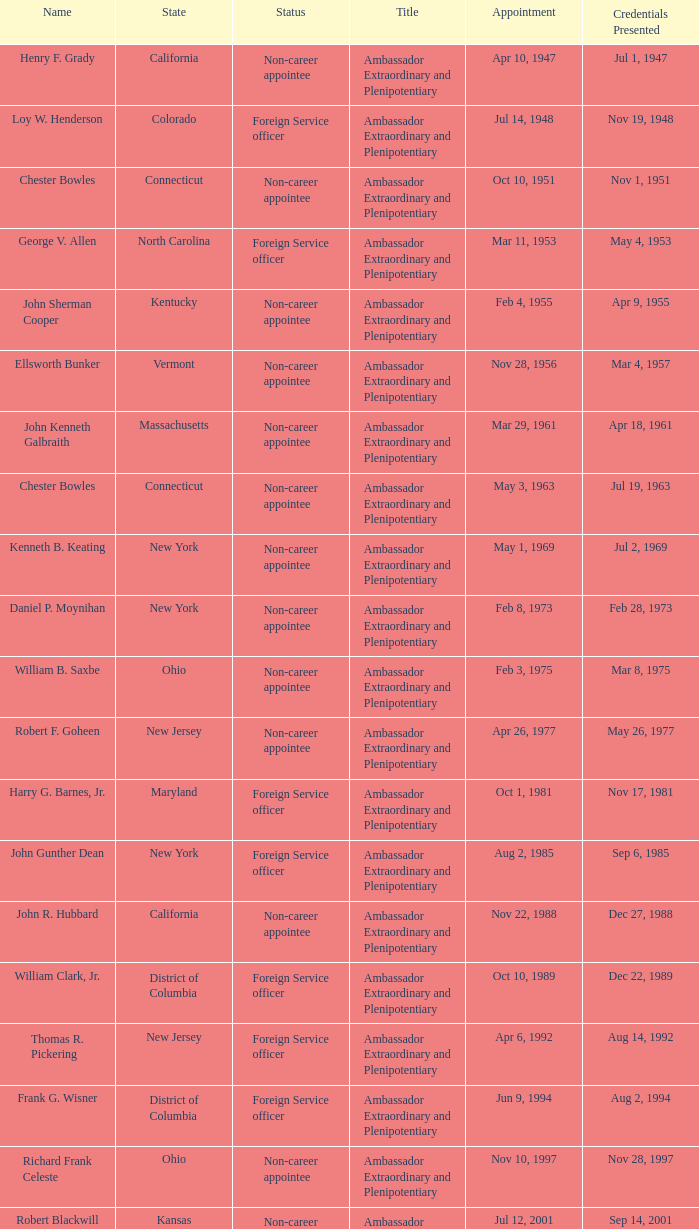When did the presentation of credentials occur for a foreign service officer in new jersey? Aug 14, 1992. 